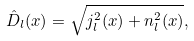<formula> <loc_0><loc_0><loc_500><loc_500>\hat { D } _ { l } ( x ) = \sqrt { j _ { l } ^ { 2 } ( x ) + n _ { l } ^ { 2 } ( x ) } ,</formula> 